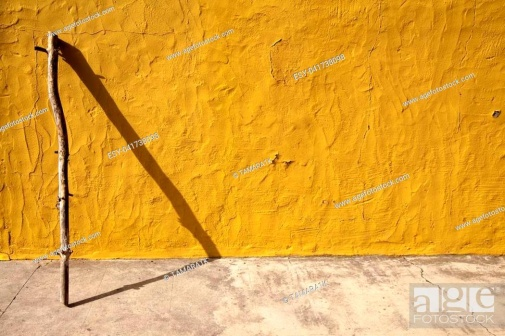What do you think is going on in this snapshot? The image captures a minimalistic scene imbued with a sense of simplicity and artistic allure. A singular brown stick, notably tall and slender, is positioned at the left side of the frame, leaning gracefully against a vivid yellow, textured wall. The shadow of the stick, a dark and elongated silhouette, stretches prominently to the right, cast by an unseen light source that adds dramatic depth and dimension to the composition. The contrast between the stick, its shadow, and the vibrant wall, alongside the gray ground beneath, collectively form a striking visual. The absence of other objects or text creates a serene and contemplative atmosphere, inviting viewers to ponder the interplay of light, shadow, and space. 